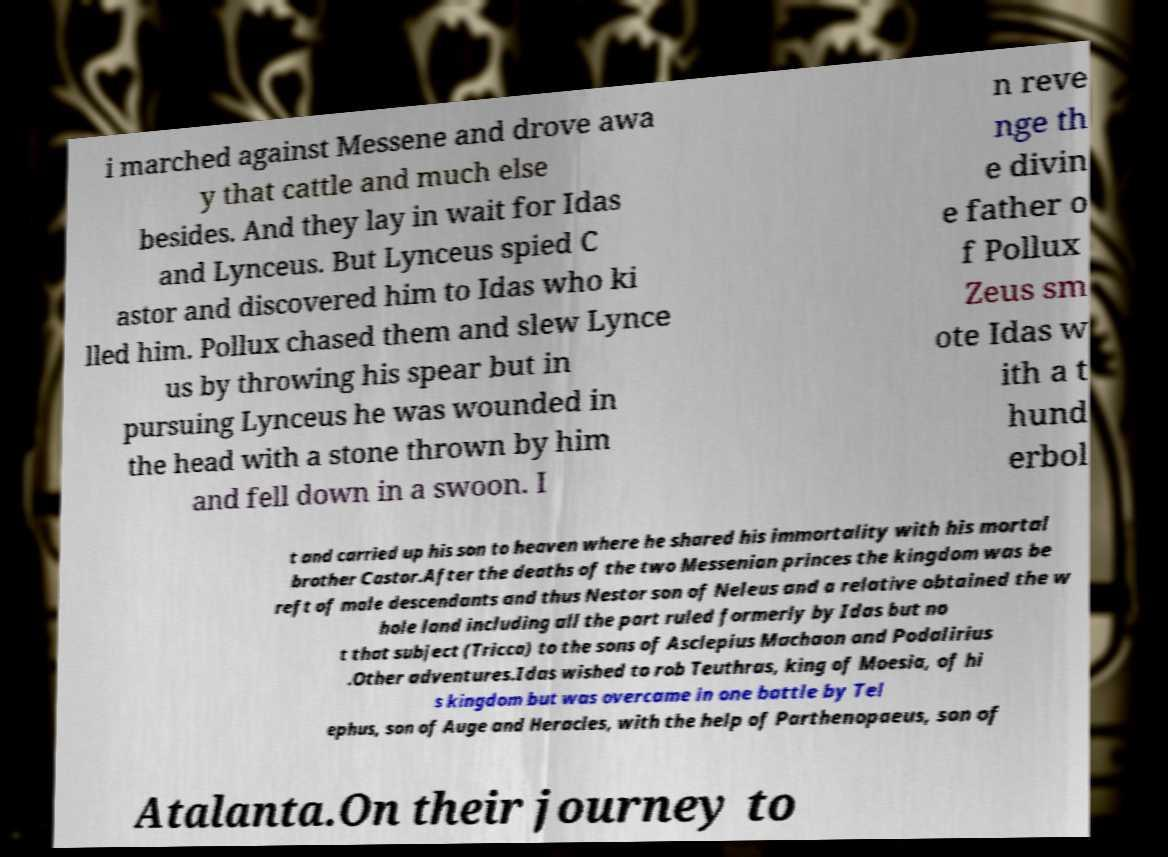I need the written content from this picture converted into text. Can you do that? i marched against Messene and drove awa y that cattle and much else besides. And they lay in wait for Idas and Lynceus. But Lynceus spied C astor and discovered him to Idas who ki lled him. Pollux chased them and slew Lynce us by throwing his spear but in pursuing Lynceus he was wounded in the head with a stone thrown by him and fell down in a swoon. I n reve nge th e divin e father o f Pollux Zeus sm ote Idas w ith a t hund erbol t and carried up his son to heaven where he shared his immortality with his mortal brother Castor.After the deaths of the two Messenian princes the kingdom was be reft of male descendants and thus Nestor son of Neleus and a relative obtained the w hole land including all the part ruled formerly by Idas but no t that subject (Tricca) to the sons of Asclepius Machaon and Podalirius .Other adventures.Idas wished to rob Teuthras, king of Moesia, of hi s kingdom but was overcame in one battle by Tel ephus, son of Auge and Heracles, with the help of Parthenopaeus, son of Atalanta.On their journey to 